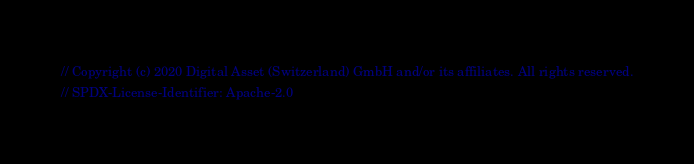Convert code to text. <code><loc_0><loc_0><loc_500><loc_500><_Scala_>// Copyright (c) 2020 Digital Asset (Switzerland) GmbH and/or its affiliates. All rights reserved.
// SPDX-License-Identifier: Apache-2.0
</code> 